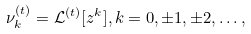<formula> <loc_0><loc_0><loc_500><loc_500>\nu _ { k } ^ { ( t ) } = \mathcal { L } ^ { ( t ) } [ z ^ { k } ] , k = 0 , \pm 1 , \pm 2 , \dots ,</formula> 